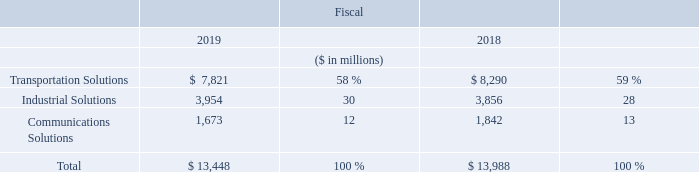Net Sales
The following table presents our net sales and the percentage of total net sales by segment:
What was the total net sales in 2019?
Answer scale should be: million. $ 13,448. What was the total Transportation Solutions sales in 2018?
Answer scale should be: million. $ 8,290. What are the segments for which the net sales are presented in the table? Transportation solutions, industrial solutions, communications solutions. In which year was Industrial Solutions larger? 3,954>3,856
Answer: 2019. What was the change in Industrial Solutions in 2019 from 2018?
Answer scale should be: million. 3,954-3,856
Answer: 98. What was the percentage change in Industrial Solutions in 2019 from 2018?
Answer scale should be: percent. (3,954-3,856)/3,856
Answer: 2.54. 